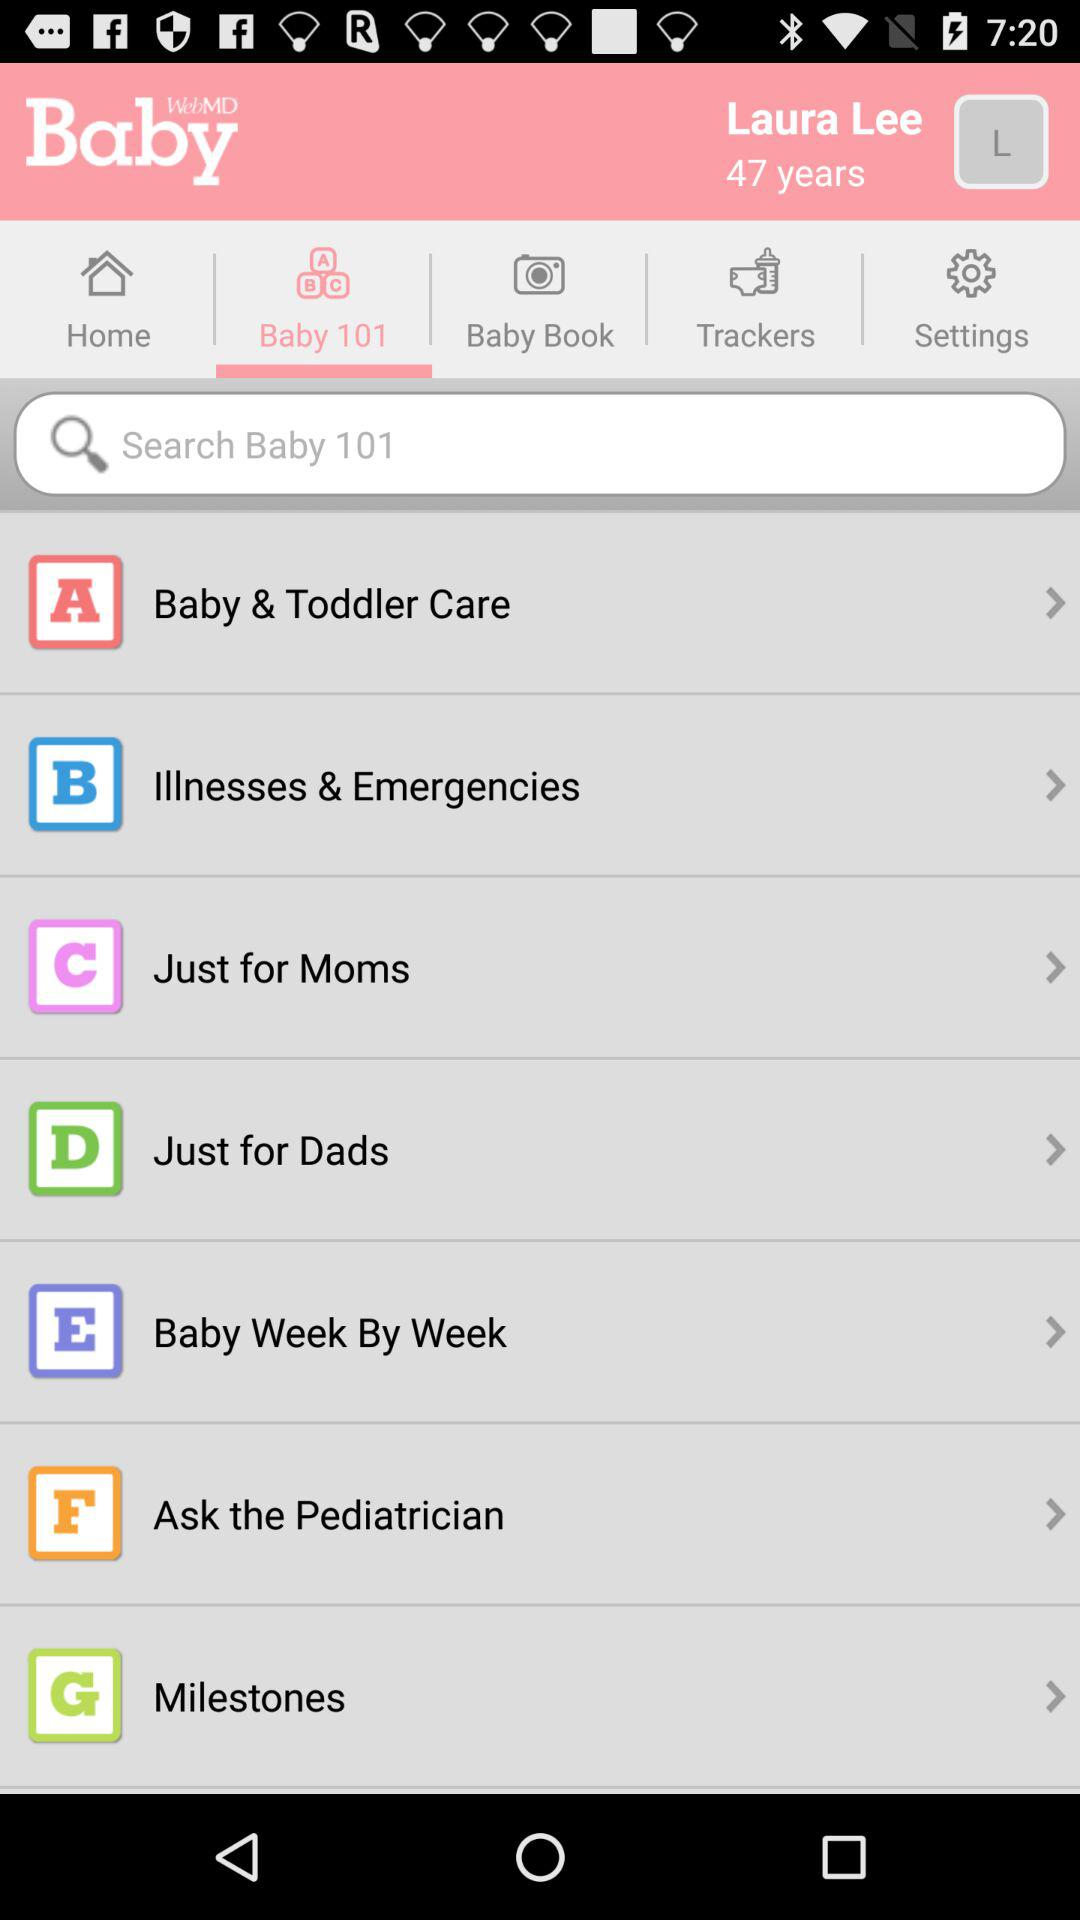What is the age of the person? The age is 47 years. 